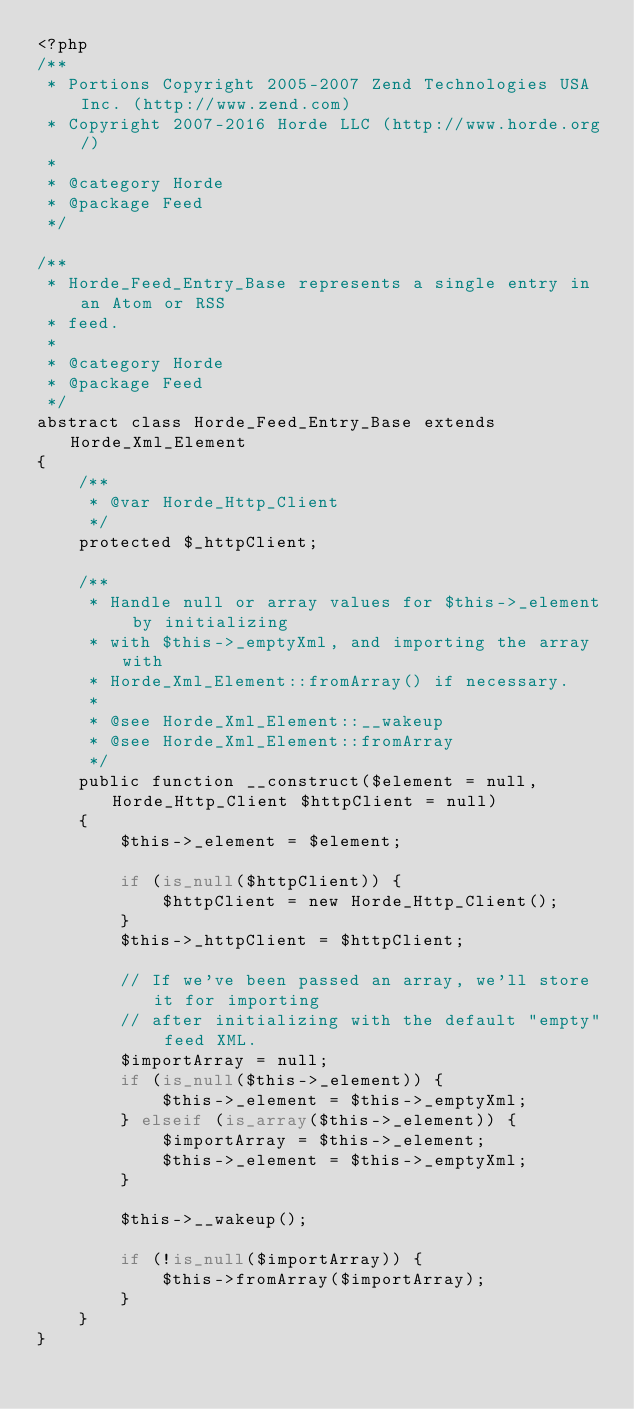<code> <loc_0><loc_0><loc_500><loc_500><_PHP_><?php
/**
 * Portions Copyright 2005-2007 Zend Technologies USA Inc. (http://www.zend.com)
 * Copyright 2007-2016 Horde LLC (http://www.horde.org/)
 *
 * @category Horde
 * @package Feed
 */

/**
 * Horde_Feed_Entry_Base represents a single entry in an Atom or RSS
 * feed.
 *
 * @category Horde
 * @package Feed
 */
abstract class Horde_Feed_Entry_Base extends Horde_Xml_Element
{
    /**
     * @var Horde_Http_Client
     */
    protected $_httpClient;

    /**
     * Handle null or array values for $this->_element by initializing
     * with $this->_emptyXml, and importing the array with
     * Horde_Xml_Element::fromArray() if necessary.
     *
     * @see Horde_Xml_Element::__wakeup
     * @see Horde_Xml_Element::fromArray
     */
    public function __construct($element = null, Horde_Http_Client $httpClient = null)
    {
        $this->_element = $element;

        if (is_null($httpClient)) {
            $httpClient = new Horde_Http_Client();
        }
        $this->_httpClient = $httpClient;

        // If we've been passed an array, we'll store it for importing
        // after initializing with the default "empty" feed XML.
        $importArray = null;
        if (is_null($this->_element)) {
            $this->_element = $this->_emptyXml;
        } elseif (is_array($this->_element)) {
            $importArray = $this->_element;
            $this->_element = $this->_emptyXml;
        }

        $this->__wakeup();

        if (!is_null($importArray)) {
            $this->fromArray($importArray);
        }
    }
}
</code> 